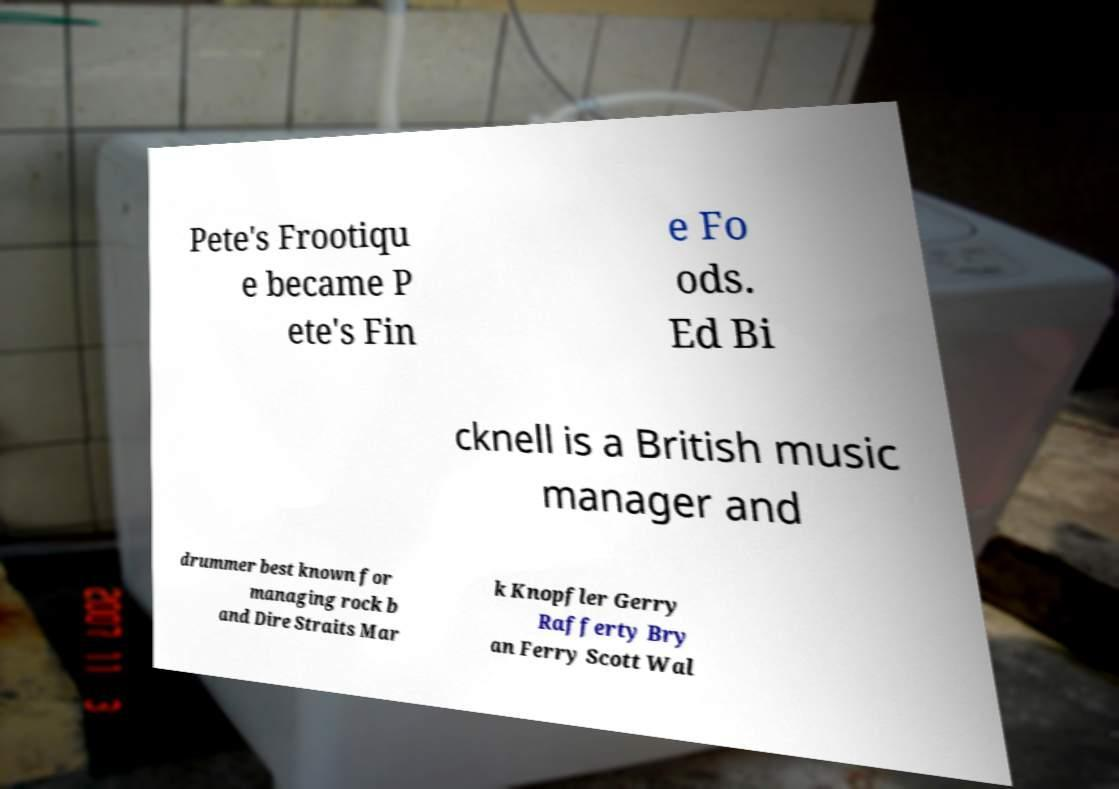Please read and relay the text visible in this image. What does it say? Pete's Frootiqu e became P ete's Fin e Fo ods. Ed Bi cknell is a British music manager and drummer best known for managing rock b and Dire Straits Mar k Knopfler Gerry Rafferty Bry an Ferry Scott Wal 